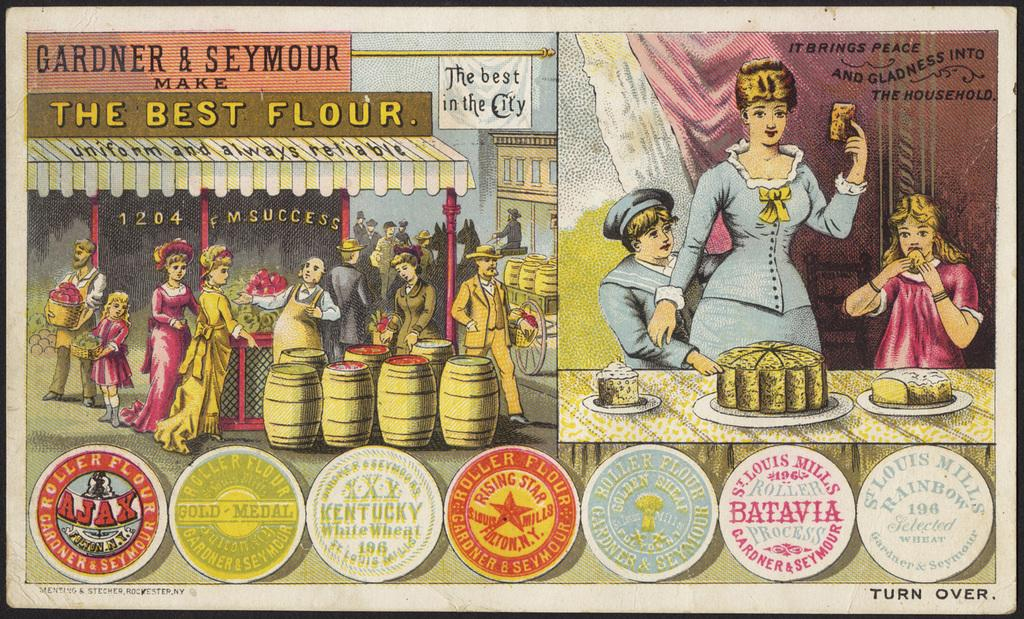<image>
Offer a succinct explanation of the picture presented. An advertisement for Gardner and Seymour saying they make the best flour. 